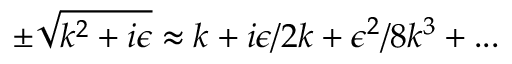<formula> <loc_0><loc_0><loc_500><loc_500>\pm \sqrt { k ^ { 2 } + i \epsilon } \approx k + i \epsilon / 2 k + \epsilon ^ { 2 } / 8 k ^ { 3 } + \dots</formula> 